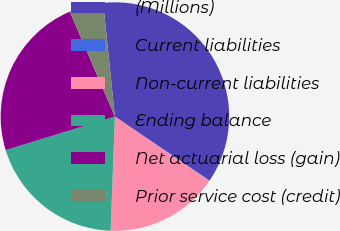<chart> <loc_0><loc_0><loc_500><loc_500><pie_chart><fcel>(Millions)<fcel>Current liabilities<fcel>Non-current liabilities<fcel>Ending balance<fcel>Net actuarial loss (gain)<fcel>Prior service cost (credit)<nl><fcel>36.1%<fcel>0.07%<fcel>16.07%<fcel>19.67%<fcel>23.27%<fcel>4.83%<nl></chart> 